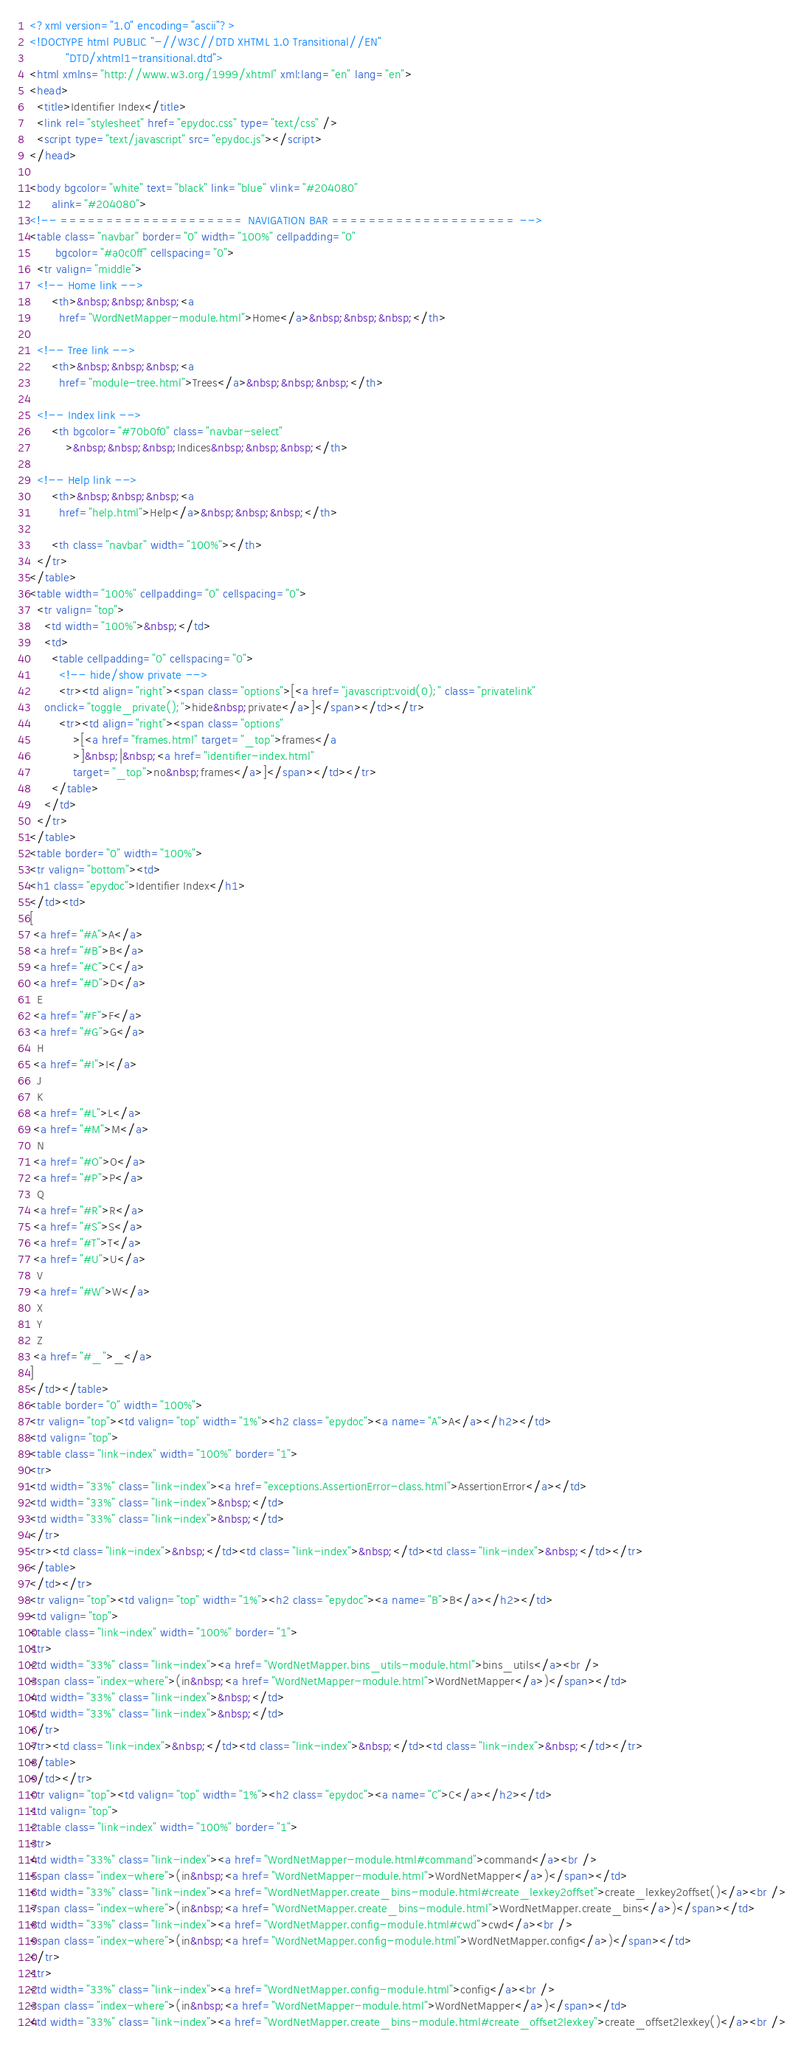Convert code to text. <code><loc_0><loc_0><loc_500><loc_500><_HTML_><?xml version="1.0" encoding="ascii"?>
<!DOCTYPE html PUBLIC "-//W3C//DTD XHTML 1.0 Transitional//EN"
          "DTD/xhtml1-transitional.dtd">
<html xmlns="http://www.w3.org/1999/xhtml" xml:lang="en" lang="en">
<head>
  <title>Identifier Index</title>
  <link rel="stylesheet" href="epydoc.css" type="text/css" />
  <script type="text/javascript" src="epydoc.js"></script>
</head>

<body bgcolor="white" text="black" link="blue" vlink="#204080"
      alink="#204080">
<!-- ==================== NAVIGATION BAR ==================== -->
<table class="navbar" border="0" width="100%" cellpadding="0"
       bgcolor="#a0c0ff" cellspacing="0">
  <tr valign="middle">
  <!-- Home link -->
      <th>&nbsp;&nbsp;&nbsp;<a
        href="WordNetMapper-module.html">Home</a>&nbsp;&nbsp;&nbsp;</th>

  <!-- Tree link -->
      <th>&nbsp;&nbsp;&nbsp;<a
        href="module-tree.html">Trees</a>&nbsp;&nbsp;&nbsp;</th>

  <!-- Index link -->
      <th bgcolor="#70b0f0" class="navbar-select"
          >&nbsp;&nbsp;&nbsp;Indices&nbsp;&nbsp;&nbsp;</th>

  <!-- Help link -->
      <th>&nbsp;&nbsp;&nbsp;<a
        href="help.html">Help</a>&nbsp;&nbsp;&nbsp;</th>

      <th class="navbar" width="100%"></th>
  </tr>
</table>
<table width="100%" cellpadding="0" cellspacing="0">
  <tr valign="top">
    <td width="100%">&nbsp;</td>
    <td>
      <table cellpadding="0" cellspacing="0">
        <!-- hide/show private -->
        <tr><td align="right"><span class="options">[<a href="javascript:void(0);" class="privatelink"
    onclick="toggle_private();">hide&nbsp;private</a>]</span></td></tr>
        <tr><td align="right"><span class="options"
            >[<a href="frames.html" target="_top">frames</a
            >]&nbsp;|&nbsp;<a href="identifier-index.html"
            target="_top">no&nbsp;frames</a>]</span></td></tr>
      </table>
    </td>
  </tr>
</table>
<table border="0" width="100%">
<tr valign="bottom"><td>
<h1 class="epydoc">Identifier Index</h1>
</td><td>
[
 <a href="#A">A</a>
 <a href="#B">B</a>
 <a href="#C">C</a>
 <a href="#D">D</a>
  E
 <a href="#F">F</a>
 <a href="#G">G</a>
  H
 <a href="#I">I</a>
  J
  K
 <a href="#L">L</a>
 <a href="#M">M</a>
  N
 <a href="#O">O</a>
 <a href="#P">P</a>
  Q
 <a href="#R">R</a>
 <a href="#S">S</a>
 <a href="#T">T</a>
 <a href="#U">U</a>
  V
 <a href="#W">W</a>
  X
  Y
  Z
 <a href="#_">_</a>
]
</td></table>
<table border="0" width="100%">
<tr valign="top"><td valign="top" width="1%"><h2 class="epydoc"><a name="A">A</a></h2></td>
<td valign="top">
<table class="link-index" width="100%" border="1">
<tr>
<td width="33%" class="link-index"><a href="exceptions.AssertionError-class.html">AssertionError</a></td>
<td width="33%" class="link-index">&nbsp;</td>
<td width="33%" class="link-index">&nbsp;</td>
</tr>
<tr><td class="link-index">&nbsp;</td><td class="link-index">&nbsp;</td><td class="link-index">&nbsp;</td></tr>
</table>
</td></tr>
<tr valign="top"><td valign="top" width="1%"><h2 class="epydoc"><a name="B">B</a></h2></td>
<td valign="top">
<table class="link-index" width="100%" border="1">
<tr>
<td width="33%" class="link-index"><a href="WordNetMapper.bins_utils-module.html">bins_utils</a><br />
<span class="index-where">(in&nbsp;<a href="WordNetMapper-module.html">WordNetMapper</a>)</span></td>
<td width="33%" class="link-index">&nbsp;</td>
<td width="33%" class="link-index">&nbsp;</td>
</tr>
<tr><td class="link-index">&nbsp;</td><td class="link-index">&nbsp;</td><td class="link-index">&nbsp;</td></tr>
</table>
</td></tr>
<tr valign="top"><td valign="top" width="1%"><h2 class="epydoc"><a name="C">C</a></h2></td>
<td valign="top">
<table class="link-index" width="100%" border="1">
<tr>
<td width="33%" class="link-index"><a href="WordNetMapper-module.html#command">command</a><br />
<span class="index-where">(in&nbsp;<a href="WordNetMapper-module.html">WordNetMapper</a>)</span></td>
<td width="33%" class="link-index"><a href="WordNetMapper.create_bins-module.html#create_lexkey2offset">create_lexkey2offset()</a><br />
<span class="index-where">(in&nbsp;<a href="WordNetMapper.create_bins-module.html">WordNetMapper.create_bins</a>)</span></td>
<td width="33%" class="link-index"><a href="WordNetMapper.config-module.html#cwd">cwd</a><br />
<span class="index-where">(in&nbsp;<a href="WordNetMapper.config-module.html">WordNetMapper.config</a>)</span></td>
</tr>
<tr>
<td width="33%" class="link-index"><a href="WordNetMapper.config-module.html">config</a><br />
<span class="index-where">(in&nbsp;<a href="WordNetMapper-module.html">WordNetMapper</a>)</span></td>
<td width="33%" class="link-index"><a href="WordNetMapper.create_bins-module.html#create_offset2lexkey">create_offset2lexkey()</a><br /></code> 